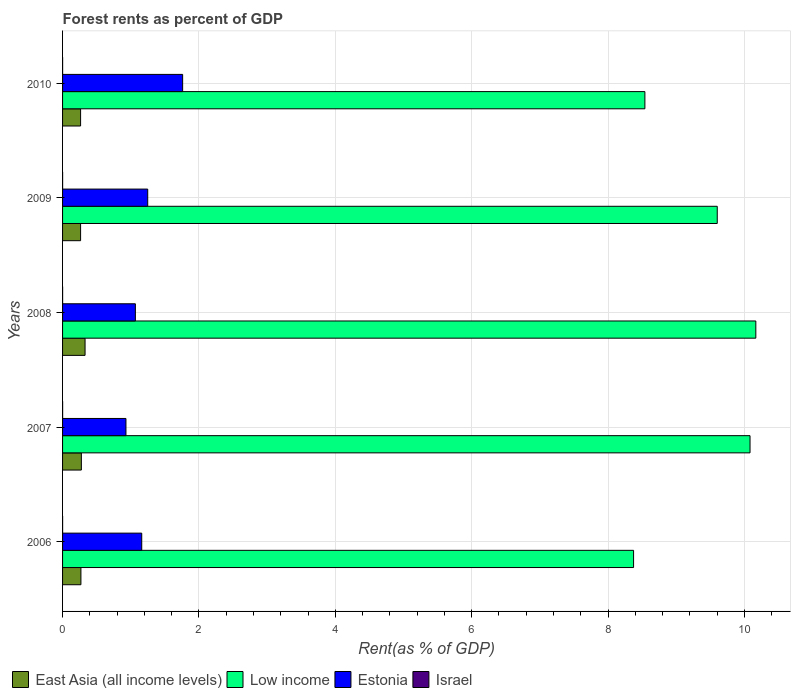How many groups of bars are there?
Your answer should be very brief. 5. Are the number of bars on each tick of the Y-axis equal?
Offer a very short reply. Yes. How many bars are there on the 5th tick from the bottom?
Your answer should be compact. 4. What is the label of the 5th group of bars from the top?
Ensure brevity in your answer.  2006. What is the forest rent in Estonia in 2007?
Ensure brevity in your answer.  0.93. Across all years, what is the maximum forest rent in Israel?
Your response must be concise. 0. Across all years, what is the minimum forest rent in East Asia (all income levels)?
Provide a succinct answer. 0.26. In which year was the forest rent in East Asia (all income levels) minimum?
Provide a succinct answer. 2009. What is the total forest rent in Estonia in the graph?
Give a very brief answer. 6.17. What is the difference between the forest rent in East Asia (all income levels) in 2006 and that in 2008?
Offer a very short reply. -0.06. What is the difference between the forest rent in Estonia in 2009 and the forest rent in Israel in 2008?
Your response must be concise. 1.25. What is the average forest rent in Estonia per year?
Your response must be concise. 1.23. In the year 2007, what is the difference between the forest rent in Estonia and forest rent in Low income?
Your answer should be compact. -9.15. What is the ratio of the forest rent in East Asia (all income levels) in 2008 to that in 2010?
Offer a terse response. 1.25. What is the difference between the highest and the second highest forest rent in Low income?
Your answer should be compact. 0.09. What is the difference between the highest and the lowest forest rent in East Asia (all income levels)?
Keep it short and to the point. 0.07. Is it the case that in every year, the sum of the forest rent in Estonia and forest rent in Low income is greater than the sum of forest rent in Israel and forest rent in East Asia (all income levels)?
Offer a terse response. No. What does the 3rd bar from the top in 2007 represents?
Provide a succinct answer. Low income. How many bars are there?
Your answer should be very brief. 20. Are all the bars in the graph horizontal?
Keep it short and to the point. Yes. How many years are there in the graph?
Offer a very short reply. 5. Are the values on the major ticks of X-axis written in scientific E-notation?
Make the answer very short. No. Does the graph contain grids?
Ensure brevity in your answer.  Yes. What is the title of the graph?
Offer a terse response. Forest rents as percent of GDP. What is the label or title of the X-axis?
Provide a succinct answer. Rent(as % of GDP). What is the label or title of the Y-axis?
Give a very brief answer. Years. What is the Rent(as % of GDP) of East Asia (all income levels) in 2006?
Offer a terse response. 0.27. What is the Rent(as % of GDP) of Low income in 2006?
Make the answer very short. 8.37. What is the Rent(as % of GDP) of Estonia in 2006?
Offer a terse response. 1.16. What is the Rent(as % of GDP) of Israel in 2006?
Make the answer very short. 0. What is the Rent(as % of GDP) in East Asia (all income levels) in 2007?
Keep it short and to the point. 0.28. What is the Rent(as % of GDP) of Low income in 2007?
Offer a terse response. 10.08. What is the Rent(as % of GDP) of Estonia in 2007?
Make the answer very short. 0.93. What is the Rent(as % of GDP) in Israel in 2007?
Offer a very short reply. 0. What is the Rent(as % of GDP) in East Asia (all income levels) in 2008?
Give a very brief answer. 0.33. What is the Rent(as % of GDP) in Low income in 2008?
Make the answer very short. 10.17. What is the Rent(as % of GDP) of Estonia in 2008?
Provide a succinct answer. 1.07. What is the Rent(as % of GDP) in Israel in 2008?
Give a very brief answer. 0. What is the Rent(as % of GDP) of East Asia (all income levels) in 2009?
Your answer should be compact. 0.26. What is the Rent(as % of GDP) of Low income in 2009?
Give a very brief answer. 9.6. What is the Rent(as % of GDP) of Estonia in 2009?
Make the answer very short. 1.25. What is the Rent(as % of GDP) of Israel in 2009?
Keep it short and to the point. 0. What is the Rent(as % of GDP) of East Asia (all income levels) in 2010?
Offer a terse response. 0.26. What is the Rent(as % of GDP) in Low income in 2010?
Offer a terse response. 8.54. What is the Rent(as % of GDP) in Estonia in 2010?
Your response must be concise. 1.76. What is the Rent(as % of GDP) in Israel in 2010?
Your response must be concise. 0. Across all years, what is the maximum Rent(as % of GDP) of East Asia (all income levels)?
Keep it short and to the point. 0.33. Across all years, what is the maximum Rent(as % of GDP) of Low income?
Your answer should be very brief. 10.17. Across all years, what is the maximum Rent(as % of GDP) in Estonia?
Your answer should be very brief. 1.76. Across all years, what is the maximum Rent(as % of GDP) of Israel?
Give a very brief answer. 0. Across all years, what is the minimum Rent(as % of GDP) in East Asia (all income levels)?
Your answer should be very brief. 0.26. Across all years, what is the minimum Rent(as % of GDP) of Low income?
Your response must be concise. 8.37. Across all years, what is the minimum Rent(as % of GDP) in Estonia?
Provide a succinct answer. 0.93. Across all years, what is the minimum Rent(as % of GDP) of Israel?
Provide a succinct answer. 0. What is the total Rent(as % of GDP) of East Asia (all income levels) in the graph?
Offer a very short reply. 1.4. What is the total Rent(as % of GDP) in Low income in the graph?
Your answer should be compact. 46.76. What is the total Rent(as % of GDP) of Estonia in the graph?
Your answer should be compact. 6.17. What is the total Rent(as % of GDP) of Israel in the graph?
Provide a succinct answer. 0. What is the difference between the Rent(as % of GDP) in East Asia (all income levels) in 2006 and that in 2007?
Keep it short and to the point. -0.01. What is the difference between the Rent(as % of GDP) of Low income in 2006 and that in 2007?
Offer a very short reply. -1.71. What is the difference between the Rent(as % of GDP) of Estonia in 2006 and that in 2007?
Make the answer very short. 0.23. What is the difference between the Rent(as % of GDP) in Israel in 2006 and that in 2007?
Give a very brief answer. -0. What is the difference between the Rent(as % of GDP) in East Asia (all income levels) in 2006 and that in 2008?
Offer a very short reply. -0.06. What is the difference between the Rent(as % of GDP) in Low income in 2006 and that in 2008?
Your answer should be compact. -1.79. What is the difference between the Rent(as % of GDP) of Estonia in 2006 and that in 2008?
Your answer should be compact. 0.09. What is the difference between the Rent(as % of GDP) of Israel in 2006 and that in 2008?
Your response must be concise. 0. What is the difference between the Rent(as % of GDP) in East Asia (all income levels) in 2006 and that in 2009?
Provide a succinct answer. 0.01. What is the difference between the Rent(as % of GDP) of Low income in 2006 and that in 2009?
Your response must be concise. -1.23. What is the difference between the Rent(as % of GDP) of Estonia in 2006 and that in 2009?
Keep it short and to the point. -0.09. What is the difference between the Rent(as % of GDP) of Israel in 2006 and that in 2009?
Ensure brevity in your answer.  0. What is the difference between the Rent(as % of GDP) of East Asia (all income levels) in 2006 and that in 2010?
Offer a very short reply. 0. What is the difference between the Rent(as % of GDP) in Low income in 2006 and that in 2010?
Your answer should be very brief. -0.17. What is the difference between the Rent(as % of GDP) in Estonia in 2006 and that in 2010?
Ensure brevity in your answer.  -0.6. What is the difference between the Rent(as % of GDP) in East Asia (all income levels) in 2007 and that in 2008?
Ensure brevity in your answer.  -0.05. What is the difference between the Rent(as % of GDP) of Low income in 2007 and that in 2008?
Ensure brevity in your answer.  -0.09. What is the difference between the Rent(as % of GDP) of Estonia in 2007 and that in 2008?
Provide a succinct answer. -0.14. What is the difference between the Rent(as % of GDP) of East Asia (all income levels) in 2007 and that in 2009?
Ensure brevity in your answer.  0.01. What is the difference between the Rent(as % of GDP) in Low income in 2007 and that in 2009?
Give a very brief answer. 0.48. What is the difference between the Rent(as % of GDP) of Estonia in 2007 and that in 2009?
Your response must be concise. -0.32. What is the difference between the Rent(as % of GDP) in Israel in 2007 and that in 2009?
Your response must be concise. 0. What is the difference between the Rent(as % of GDP) in East Asia (all income levels) in 2007 and that in 2010?
Make the answer very short. 0.01. What is the difference between the Rent(as % of GDP) of Low income in 2007 and that in 2010?
Make the answer very short. 1.54. What is the difference between the Rent(as % of GDP) in Estonia in 2007 and that in 2010?
Offer a very short reply. -0.83. What is the difference between the Rent(as % of GDP) of East Asia (all income levels) in 2008 and that in 2009?
Offer a terse response. 0.07. What is the difference between the Rent(as % of GDP) in Low income in 2008 and that in 2009?
Give a very brief answer. 0.57. What is the difference between the Rent(as % of GDP) in Estonia in 2008 and that in 2009?
Make the answer very short. -0.18. What is the difference between the Rent(as % of GDP) in Israel in 2008 and that in 2009?
Keep it short and to the point. 0. What is the difference between the Rent(as % of GDP) of East Asia (all income levels) in 2008 and that in 2010?
Offer a terse response. 0.07. What is the difference between the Rent(as % of GDP) in Low income in 2008 and that in 2010?
Keep it short and to the point. 1.63. What is the difference between the Rent(as % of GDP) in Estonia in 2008 and that in 2010?
Provide a succinct answer. -0.69. What is the difference between the Rent(as % of GDP) in East Asia (all income levels) in 2009 and that in 2010?
Your response must be concise. -0. What is the difference between the Rent(as % of GDP) in Low income in 2009 and that in 2010?
Your answer should be very brief. 1.06. What is the difference between the Rent(as % of GDP) of Estonia in 2009 and that in 2010?
Make the answer very short. -0.51. What is the difference between the Rent(as % of GDP) in Israel in 2009 and that in 2010?
Your response must be concise. 0. What is the difference between the Rent(as % of GDP) of East Asia (all income levels) in 2006 and the Rent(as % of GDP) of Low income in 2007?
Provide a short and direct response. -9.81. What is the difference between the Rent(as % of GDP) of East Asia (all income levels) in 2006 and the Rent(as % of GDP) of Estonia in 2007?
Give a very brief answer. -0.66. What is the difference between the Rent(as % of GDP) in East Asia (all income levels) in 2006 and the Rent(as % of GDP) in Israel in 2007?
Provide a succinct answer. 0.27. What is the difference between the Rent(as % of GDP) in Low income in 2006 and the Rent(as % of GDP) in Estonia in 2007?
Give a very brief answer. 7.44. What is the difference between the Rent(as % of GDP) of Low income in 2006 and the Rent(as % of GDP) of Israel in 2007?
Keep it short and to the point. 8.37. What is the difference between the Rent(as % of GDP) in Estonia in 2006 and the Rent(as % of GDP) in Israel in 2007?
Provide a succinct answer. 1.16. What is the difference between the Rent(as % of GDP) of East Asia (all income levels) in 2006 and the Rent(as % of GDP) of Low income in 2008?
Provide a short and direct response. -9.9. What is the difference between the Rent(as % of GDP) in East Asia (all income levels) in 2006 and the Rent(as % of GDP) in Estonia in 2008?
Your answer should be very brief. -0.8. What is the difference between the Rent(as % of GDP) in East Asia (all income levels) in 2006 and the Rent(as % of GDP) in Israel in 2008?
Your answer should be compact. 0.27. What is the difference between the Rent(as % of GDP) of Low income in 2006 and the Rent(as % of GDP) of Estonia in 2008?
Provide a succinct answer. 7.31. What is the difference between the Rent(as % of GDP) in Low income in 2006 and the Rent(as % of GDP) in Israel in 2008?
Give a very brief answer. 8.37. What is the difference between the Rent(as % of GDP) of Estonia in 2006 and the Rent(as % of GDP) of Israel in 2008?
Your answer should be very brief. 1.16. What is the difference between the Rent(as % of GDP) in East Asia (all income levels) in 2006 and the Rent(as % of GDP) in Low income in 2009?
Make the answer very short. -9.33. What is the difference between the Rent(as % of GDP) in East Asia (all income levels) in 2006 and the Rent(as % of GDP) in Estonia in 2009?
Offer a terse response. -0.98. What is the difference between the Rent(as % of GDP) in East Asia (all income levels) in 2006 and the Rent(as % of GDP) in Israel in 2009?
Keep it short and to the point. 0.27. What is the difference between the Rent(as % of GDP) of Low income in 2006 and the Rent(as % of GDP) of Estonia in 2009?
Offer a terse response. 7.13. What is the difference between the Rent(as % of GDP) of Low income in 2006 and the Rent(as % of GDP) of Israel in 2009?
Your response must be concise. 8.37. What is the difference between the Rent(as % of GDP) in Estonia in 2006 and the Rent(as % of GDP) in Israel in 2009?
Your answer should be compact. 1.16. What is the difference between the Rent(as % of GDP) of East Asia (all income levels) in 2006 and the Rent(as % of GDP) of Low income in 2010?
Provide a short and direct response. -8.27. What is the difference between the Rent(as % of GDP) in East Asia (all income levels) in 2006 and the Rent(as % of GDP) in Estonia in 2010?
Keep it short and to the point. -1.49. What is the difference between the Rent(as % of GDP) of East Asia (all income levels) in 2006 and the Rent(as % of GDP) of Israel in 2010?
Provide a short and direct response. 0.27. What is the difference between the Rent(as % of GDP) in Low income in 2006 and the Rent(as % of GDP) in Estonia in 2010?
Your answer should be very brief. 6.61. What is the difference between the Rent(as % of GDP) in Low income in 2006 and the Rent(as % of GDP) in Israel in 2010?
Keep it short and to the point. 8.37. What is the difference between the Rent(as % of GDP) of Estonia in 2006 and the Rent(as % of GDP) of Israel in 2010?
Provide a succinct answer. 1.16. What is the difference between the Rent(as % of GDP) of East Asia (all income levels) in 2007 and the Rent(as % of GDP) of Low income in 2008?
Offer a very short reply. -9.89. What is the difference between the Rent(as % of GDP) of East Asia (all income levels) in 2007 and the Rent(as % of GDP) of Estonia in 2008?
Ensure brevity in your answer.  -0.79. What is the difference between the Rent(as % of GDP) in East Asia (all income levels) in 2007 and the Rent(as % of GDP) in Israel in 2008?
Offer a terse response. 0.27. What is the difference between the Rent(as % of GDP) of Low income in 2007 and the Rent(as % of GDP) of Estonia in 2008?
Offer a very short reply. 9.01. What is the difference between the Rent(as % of GDP) of Low income in 2007 and the Rent(as % of GDP) of Israel in 2008?
Provide a succinct answer. 10.08. What is the difference between the Rent(as % of GDP) in Estonia in 2007 and the Rent(as % of GDP) in Israel in 2008?
Give a very brief answer. 0.93. What is the difference between the Rent(as % of GDP) in East Asia (all income levels) in 2007 and the Rent(as % of GDP) in Low income in 2009?
Provide a succinct answer. -9.33. What is the difference between the Rent(as % of GDP) of East Asia (all income levels) in 2007 and the Rent(as % of GDP) of Estonia in 2009?
Offer a terse response. -0.97. What is the difference between the Rent(as % of GDP) in East Asia (all income levels) in 2007 and the Rent(as % of GDP) in Israel in 2009?
Keep it short and to the point. 0.28. What is the difference between the Rent(as % of GDP) of Low income in 2007 and the Rent(as % of GDP) of Estonia in 2009?
Provide a short and direct response. 8.83. What is the difference between the Rent(as % of GDP) in Low income in 2007 and the Rent(as % of GDP) in Israel in 2009?
Your answer should be very brief. 10.08. What is the difference between the Rent(as % of GDP) of Estonia in 2007 and the Rent(as % of GDP) of Israel in 2009?
Your response must be concise. 0.93. What is the difference between the Rent(as % of GDP) in East Asia (all income levels) in 2007 and the Rent(as % of GDP) in Low income in 2010?
Provide a short and direct response. -8.26. What is the difference between the Rent(as % of GDP) of East Asia (all income levels) in 2007 and the Rent(as % of GDP) of Estonia in 2010?
Your response must be concise. -1.49. What is the difference between the Rent(as % of GDP) in East Asia (all income levels) in 2007 and the Rent(as % of GDP) in Israel in 2010?
Provide a succinct answer. 0.28. What is the difference between the Rent(as % of GDP) in Low income in 2007 and the Rent(as % of GDP) in Estonia in 2010?
Make the answer very short. 8.32. What is the difference between the Rent(as % of GDP) in Low income in 2007 and the Rent(as % of GDP) in Israel in 2010?
Your answer should be compact. 10.08. What is the difference between the Rent(as % of GDP) in Estonia in 2007 and the Rent(as % of GDP) in Israel in 2010?
Your response must be concise. 0.93. What is the difference between the Rent(as % of GDP) in East Asia (all income levels) in 2008 and the Rent(as % of GDP) in Low income in 2009?
Provide a succinct answer. -9.27. What is the difference between the Rent(as % of GDP) in East Asia (all income levels) in 2008 and the Rent(as % of GDP) in Estonia in 2009?
Keep it short and to the point. -0.92. What is the difference between the Rent(as % of GDP) of East Asia (all income levels) in 2008 and the Rent(as % of GDP) of Israel in 2009?
Offer a very short reply. 0.33. What is the difference between the Rent(as % of GDP) in Low income in 2008 and the Rent(as % of GDP) in Estonia in 2009?
Give a very brief answer. 8.92. What is the difference between the Rent(as % of GDP) in Low income in 2008 and the Rent(as % of GDP) in Israel in 2009?
Give a very brief answer. 10.17. What is the difference between the Rent(as % of GDP) in Estonia in 2008 and the Rent(as % of GDP) in Israel in 2009?
Make the answer very short. 1.07. What is the difference between the Rent(as % of GDP) in East Asia (all income levels) in 2008 and the Rent(as % of GDP) in Low income in 2010?
Provide a short and direct response. -8.21. What is the difference between the Rent(as % of GDP) in East Asia (all income levels) in 2008 and the Rent(as % of GDP) in Estonia in 2010?
Provide a succinct answer. -1.43. What is the difference between the Rent(as % of GDP) in East Asia (all income levels) in 2008 and the Rent(as % of GDP) in Israel in 2010?
Provide a succinct answer. 0.33. What is the difference between the Rent(as % of GDP) of Low income in 2008 and the Rent(as % of GDP) of Estonia in 2010?
Ensure brevity in your answer.  8.41. What is the difference between the Rent(as % of GDP) of Low income in 2008 and the Rent(as % of GDP) of Israel in 2010?
Provide a succinct answer. 10.17. What is the difference between the Rent(as % of GDP) in Estonia in 2008 and the Rent(as % of GDP) in Israel in 2010?
Make the answer very short. 1.07. What is the difference between the Rent(as % of GDP) in East Asia (all income levels) in 2009 and the Rent(as % of GDP) in Low income in 2010?
Give a very brief answer. -8.28. What is the difference between the Rent(as % of GDP) of East Asia (all income levels) in 2009 and the Rent(as % of GDP) of Estonia in 2010?
Keep it short and to the point. -1.5. What is the difference between the Rent(as % of GDP) in East Asia (all income levels) in 2009 and the Rent(as % of GDP) in Israel in 2010?
Make the answer very short. 0.26. What is the difference between the Rent(as % of GDP) in Low income in 2009 and the Rent(as % of GDP) in Estonia in 2010?
Offer a terse response. 7.84. What is the difference between the Rent(as % of GDP) of Low income in 2009 and the Rent(as % of GDP) of Israel in 2010?
Offer a terse response. 9.6. What is the difference between the Rent(as % of GDP) of Estonia in 2009 and the Rent(as % of GDP) of Israel in 2010?
Your answer should be very brief. 1.25. What is the average Rent(as % of GDP) of East Asia (all income levels) per year?
Ensure brevity in your answer.  0.28. What is the average Rent(as % of GDP) in Low income per year?
Offer a terse response. 9.35. What is the average Rent(as % of GDP) of Estonia per year?
Ensure brevity in your answer.  1.23. What is the average Rent(as % of GDP) of Israel per year?
Offer a terse response. 0. In the year 2006, what is the difference between the Rent(as % of GDP) in East Asia (all income levels) and Rent(as % of GDP) in Low income?
Give a very brief answer. -8.1. In the year 2006, what is the difference between the Rent(as % of GDP) of East Asia (all income levels) and Rent(as % of GDP) of Estonia?
Your answer should be very brief. -0.89. In the year 2006, what is the difference between the Rent(as % of GDP) in East Asia (all income levels) and Rent(as % of GDP) in Israel?
Your answer should be very brief. 0.27. In the year 2006, what is the difference between the Rent(as % of GDP) in Low income and Rent(as % of GDP) in Estonia?
Your answer should be very brief. 7.21. In the year 2006, what is the difference between the Rent(as % of GDP) in Low income and Rent(as % of GDP) in Israel?
Give a very brief answer. 8.37. In the year 2006, what is the difference between the Rent(as % of GDP) of Estonia and Rent(as % of GDP) of Israel?
Make the answer very short. 1.16. In the year 2007, what is the difference between the Rent(as % of GDP) of East Asia (all income levels) and Rent(as % of GDP) of Low income?
Your answer should be compact. -9.81. In the year 2007, what is the difference between the Rent(as % of GDP) of East Asia (all income levels) and Rent(as % of GDP) of Estonia?
Ensure brevity in your answer.  -0.65. In the year 2007, what is the difference between the Rent(as % of GDP) of East Asia (all income levels) and Rent(as % of GDP) of Israel?
Keep it short and to the point. 0.27. In the year 2007, what is the difference between the Rent(as % of GDP) in Low income and Rent(as % of GDP) in Estonia?
Offer a terse response. 9.15. In the year 2007, what is the difference between the Rent(as % of GDP) of Low income and Rent(as % of GDP) of Israel?
Ensure brevity in your answer.  10.08. In the year 2007, what is the difference between the Rent(as % of GDP) in Estonia and Rent(as % of GDP) in Israel?
Your response must be concise. 0.93. In the year 2008, what is the difference between the Rent(as % of GDP) in East Asia (all income levels) and Rent(as % of GDP) in Low income?
Keep it short and to the point. -9.84. In the year 2008, what is the difference between the Rent(as % of GDP) in East Asia (all income levels) and Rent(as % of GDP) in Estonia?
Provide a short and direct response. -0.74. In the year 2008, what is the difference between the Rent(as % of GDP) of East Asia (all income levels) and Rent(as % of GDP) of Israel?
Offer a very short reply. 0.33. In the year 2008, what is the difference between the Rent(as % of GDP) of Low income and Rent(as % of GDP) of Estonia?
Ensure brevity in your answer.  9.1. In the year 2008, what is the difference between the Rent(as % of GDP) in Low income and Rent(as % of GDP) in Israel?
Offer a very short reply. 10.17. In the year 2008, what is the difference between the Rent(as % of GDP) in Estonia and Rent(as % of GDP) in Israel?
Keep it short and to the point. 1.07. In the year 2009, what is the difference between the Rent(as % of GDP) in East Asia (all income levels) and Rent(as % of GDP) in Low income?
Provide a succinct answer. -9.34. In the year 2009, what is the difference between the Rent(as % of GDP) of East Asia (all income levels) and Rent(as % of GDP) of Estonia?
Offer a very short reply. -0.98. In the year 2009, what is the difference between the Rent(as % of GDP) of East Asia (all income levels) and Rent(as % of GDP) of Israel?
Your answer should be compact. 0.26. In the year 2009, what is the difference between the Rent(as % of GDP) of Low income and Rent(as % of GDP) of Estonia?
Make the answer very short. 8.35. In the year 2009, what is the difference between the Rent(as % of GDP) of Low income and Rent(as % of GDP) of Israel?
Make the answer very short. 9.6. In the year 2009, what is the difference between the Rent(as % of GDP) of Estonia and Rent(as % of GDP) of Israel?
Ensure brevity in your answer.  1.25. In the year 2010, what is the difference between the Rent(as % of GDP) in East Asia (all income levels) and Rent(as % of GDP) in Low income?
Ensure brevity in your answer.  -8.28. In the year 2010, what is the difference between the Rent(as % of GDP) of East Asia (all income levels) and Rent(as % of GDP) of Estonia?
Give a very brief answer. -1.5. In the year 2010, what is the difference between the Rent(as % of GDP) of East Asia (all income levels) and Rent(as % of GDP) of Israel?
Your response must be concise. 0.26. In the year 2010, what is the difference between the Rent(as % of GDP) of Low income and Rent(as % of GDP) of Estonia?
Keep it short and to the point. 6.78. In the year 2010, what is the difference between the Rent(as % of GDP) in Low income and Rent(as % of GDP) in Israel?
Your answer should be compact. 8.54. In the year 2010, what is the difference between the Rent(as % of GDP) of Estonia and Rent(as % of GDP) of Israel?
Offer a terse response. 1.76. What is the ratio of the Rent(as % of GDP) in East Asia (all income levels) in 2006 to that in 2007?
Make the answer very short. 0.98. What is the ratio of the Rent(as % of GDP) in Low income in 2006 to that in 2007?
Offer a terse response. 0.83. What is the ratio of the Rent(as % of GDP) in Estonia in 2006 to that in 2007?
Provide a short and direct response. 1.25. What is the ratio of the Rent(as % of GDP) of Israel in 2006 to that in 2007?
Keep it short and to the point. 0.93. What is the ratio of the Rent(as % of GDP) of East Asia (all income levels) in 2006 to that in 2008?
Offer a very short reply. 0.82. What is the ratio of the Rent(as % of GDP) in Low income in 2006 to that in 2008?
Offer a terse response. 0.82. What is the ratio of the Rent(as % of GDP) of Estonia in 2006 to that in 2008?
Offer a terse response. 1.09. What is the ratio of the Rent(as % of GDP) of East Asia (all income levels) in 2006 to that in 2009?
Give a very brief answer. 1.02. What is the ratio of the Rent(as % of GDP) of Low income in 2006 to that in 2009?
Make the answer very short. 0.87. What is the ratio of the Rent(as % of GDP) in Estonia in 2006 to that in 2009?
Ensure brevity in your answer.  0.93. What is the ratio of the Rent(as % of GDP) of Israel in 2006 to that in 2009?
Make the answer very short. 1.15. What is the ratio of the Rent(as % of GDP) in East Asia (all income levels) in 2006 to that in 2010?
Offer a very short reply. 1.02. What is the ratio of the Rent(as % of GDP) of Low income in 2006 to that in 2010?
Provide a short and direct response. 0.98. What is the ratio of the Rent(as % of GDP) in Estonia in 2006 to that in 2010?
Your answer should be very brief. 0.66. What is the ratio of the Rent(as % of GDP) of Israel in 2006 to that in 2010?
Offer a very short reply. 1.16. What is the ratio of the Rent(as % of GDP) in East Asia (all income levels) in 2007 to that in 2008?
Give a very brief answer. 0.84. What is the ratio of the Rent(as % of GDP) of Low income in 2007 to that in 2008?
Your answer should be very brief. 0.99. What is the ratio of the Rent(as % of GDP) of Estonia in 2007 to that in 2008?
Provide a short and direct response. 0.87. What is the ratio of the Rent(as % of GDP) in Israel in 2007 to that in 2008?
Ensure brevity in your answer.  1.08. What is the ratio of the Rent(as % of GDP) of East Asia (all income levels) in 2007 to that in 2009?
Offer a very short reply. 1.04. What is the ratio of the Rent(as % of GDP) of Low income in 2007 to that in 2009?
Your response must be concise. 1.05. What is the ratio of the Rent(as % of GDP) of Estonia in 2007 to that in 2009?
Your answer should be compact. 0.74. What is the ratio of the Rent(as % of GDP) of Israel in 2007 to that in 2009?
Your answer should be compact. 1.23. What is the ratio of the Rent(as % of GDP) in East Asia (all income levels) in 2007 to that in 2010?
Give a very brief answer. 1.04. What is the ratio of the Rent(as % of GDP) in Low income in 2007 to that in 2010?
Make the answer very short. 1.18. What is the ratio of the Rent(as % of GDP) of Estonia in 2007 to that in 2010?
Your answer should be compact. 0.53. What is the ratio of the Rent(as % of GDP) of Israel in 2007 to that in 2010?
Provide a succinct answer. 1.25. What is the ratio of the Rent(as % of GDP) of East Asia (all income levels) in 2008 to that in 2009?
Your answer should be compact. 1.25. What is the ratio of the Rent(as % of GDP) in Low income in 2008 to that in 2009?
Your answer should be compact. 1.06. What is the ratio of the Rent(as % of GDP) of Estonia in 2008 to that in 2009?
Your answer should be compact. 0.85. What is the ratio of the Rent(as % of GDP) in Israel in 2008 to that in 2009?
Offer a terse response. 1.14. What is the ratio of the Rent(as % of GDP) in East Asia (all income levels) in 2008 to that in 2010?
Ensure brevity in your answer.  1.25. What is the ratio of the Rent(as % of GDP) in Low income in 2008 to that in 2010?
Give a very brief answer. 1.19. What is the ratio of the Rent(as % of GDP) in Estonia in 2008 to that in 2010?
Provide a short and direct response. 0.61. What is the ratio of the Rent(as % of GDP) of Israel in 2008 to that in 2010?
Your answer should be very brief. 1.16. What is the ratio of the Rent(as % of GDP) of East Asia (all income levels) in 2009 to that in 2010?
Make the answer very short. 1. What is the ratio of the Rent(as % of GDP) of Low income in 2009 to that in 2010?
Your answer should be compact. 1.12. What is the ratio of the Rent(as % of GDP) of Estonia in 2009 to that in 2010?
Provide a short and direct response. 0.71. What is the ratio of the Rent(as % of GDP) in Israel in 2009 to that in 2010?
Give a very brief answer. 1.01. What is the difference between the highest and the second highest Rent(as % of GDP) in East Asia (all income levels)?
Make the answer very short. 0.05. What is the difference between the highest and the second highest Rent(as % of GDP) in Low income?
Provide a short and direct response. 0.09. What is the difference between the highest and the second highest Rent(as % of GDP) of Estonia?
Provide a short and direct response. 0.51. What is the difference between the highest and the lowest Rent(as % of GDP) in East Asia (all income levels)?
Give a very brief answer. 0.07. What is the difference between the highest and the lowest Rent(as % of GDP) in Low income?
Your response must be concise. 1.79. What is the difference between the highest and the lowest Rent(as % of GDP) in Estonia?
Your response must be concise. 0.83. What is the difference between the highest and the lowest Rent(as % of GDP) in Israel?
Provide a succinct answer. 0. 